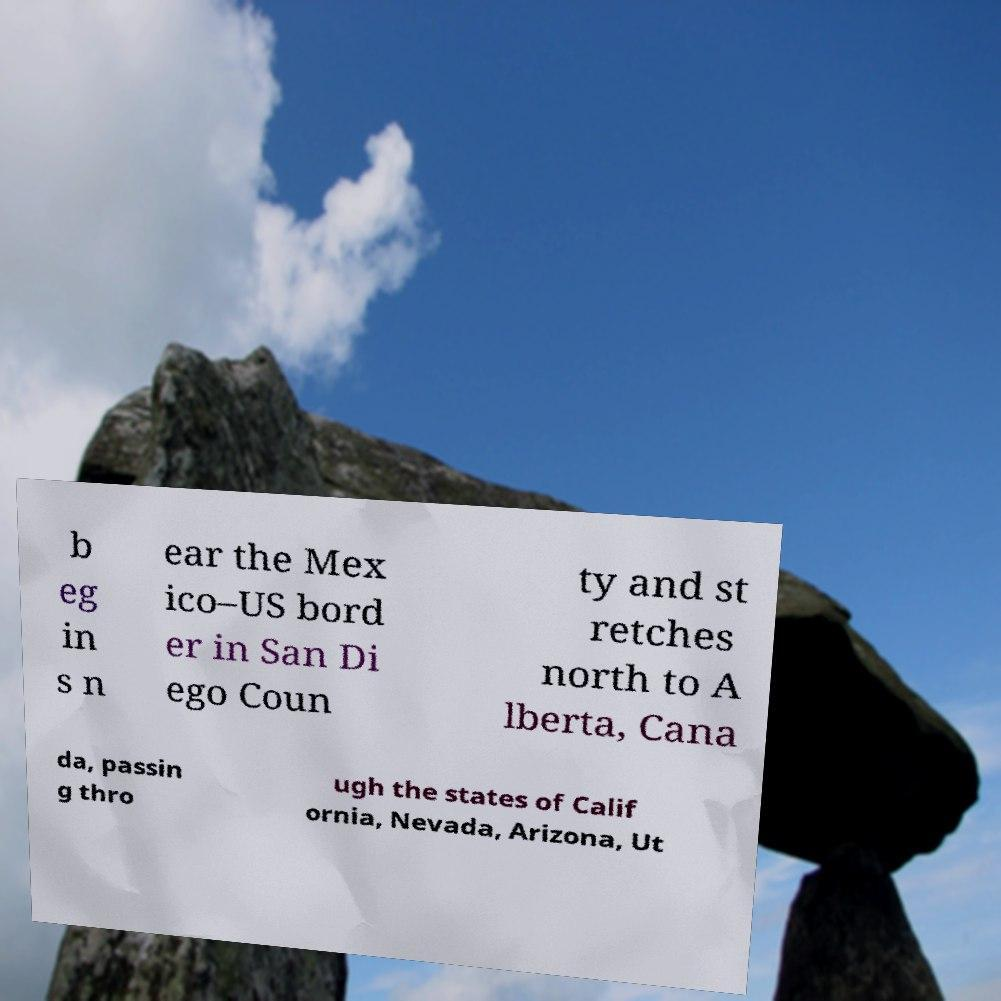Please read and relay the text visible in this image. What does it say? b eg in s n ear the Mex ico–US bord er in San Di ego Coun ty and st retches north to A lberta, Cana da, passin g thro ugh the states of Calif ornia, Nevada, Arizona, Ut 